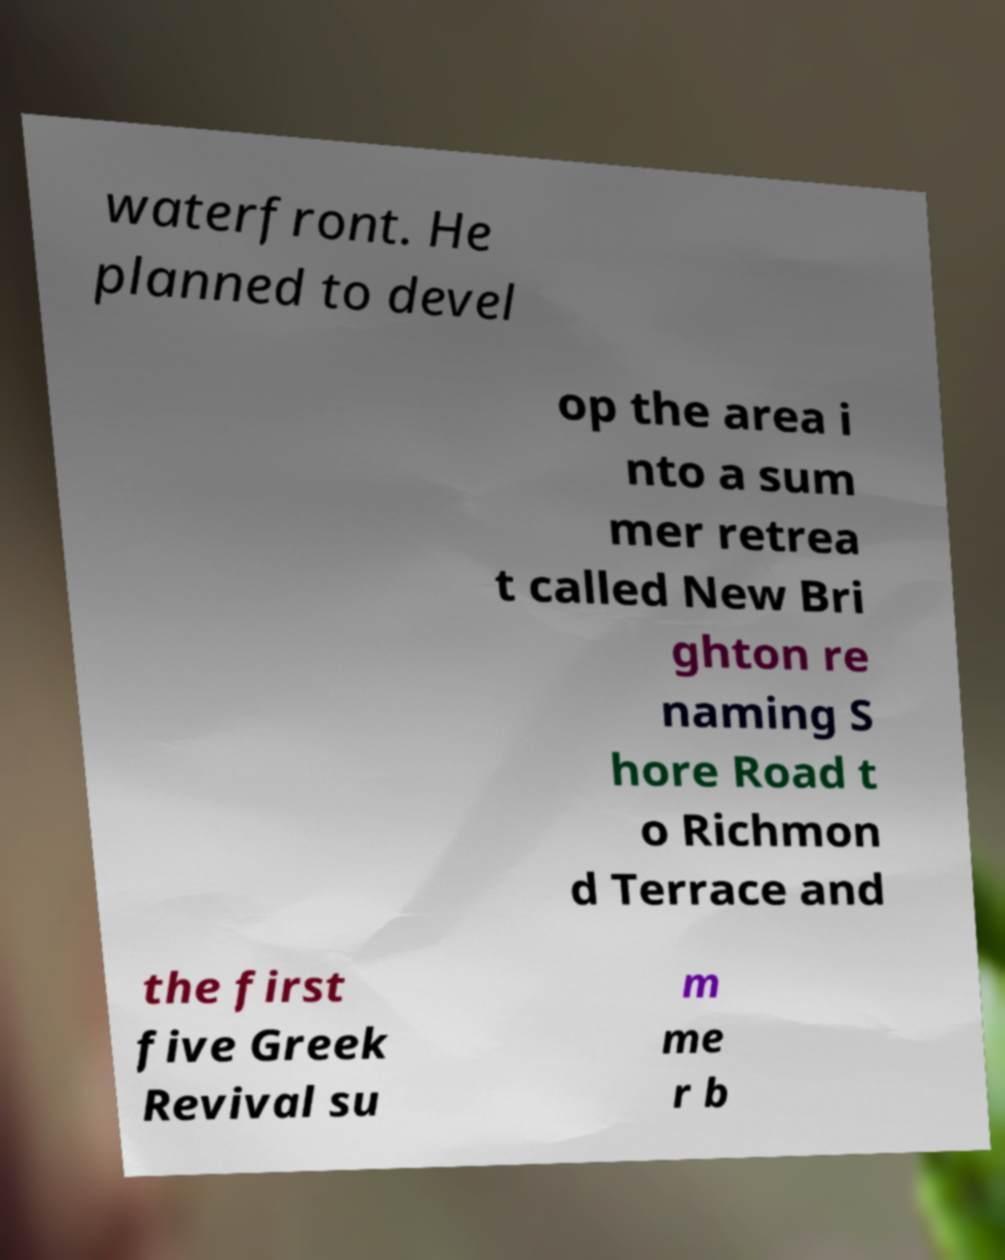Please read and relay the text visible in this image. What does it say? waterfront. He planned to devel op the area i nto a sum mer retrea t called New Bri ghton re naming S hore Road t o Richmon d Terrace and the first five Greek Revival su m me r b 